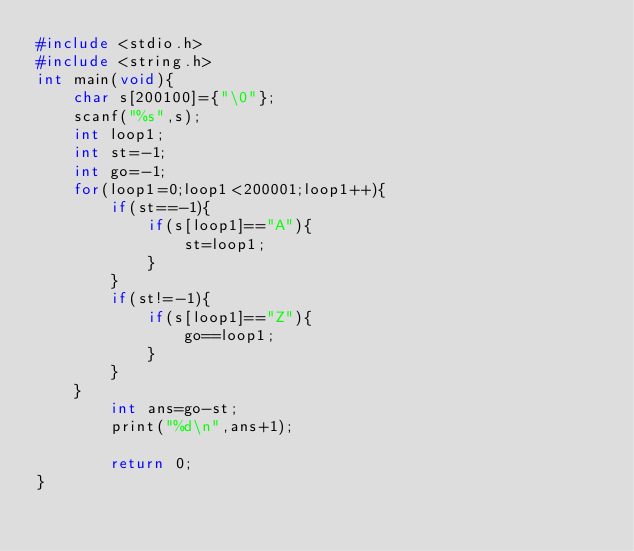Convert code to text. <code><loc_0><loc_0><loc_500><loc_500><_C_>#include <stdio.h>
#include <string.h>
int main(void){
	char s[200100]={"\0"};
	scanf("%s",s);
	int loop1;
	int st=-1;
	int go=-1;
	for(loop1=0;loop1<200001;loop1++){
		if(st==-1){
			if(s[loop1]=="A"){
				st=loop1;
			}
		}
		if(st!=-1){
			if(s[loop1]=="Z"){
				go==loop1;
			}
		}
	}
		int ans=go-st;
		print("%d\n",ans+1);

		return 0;
}
</code> 